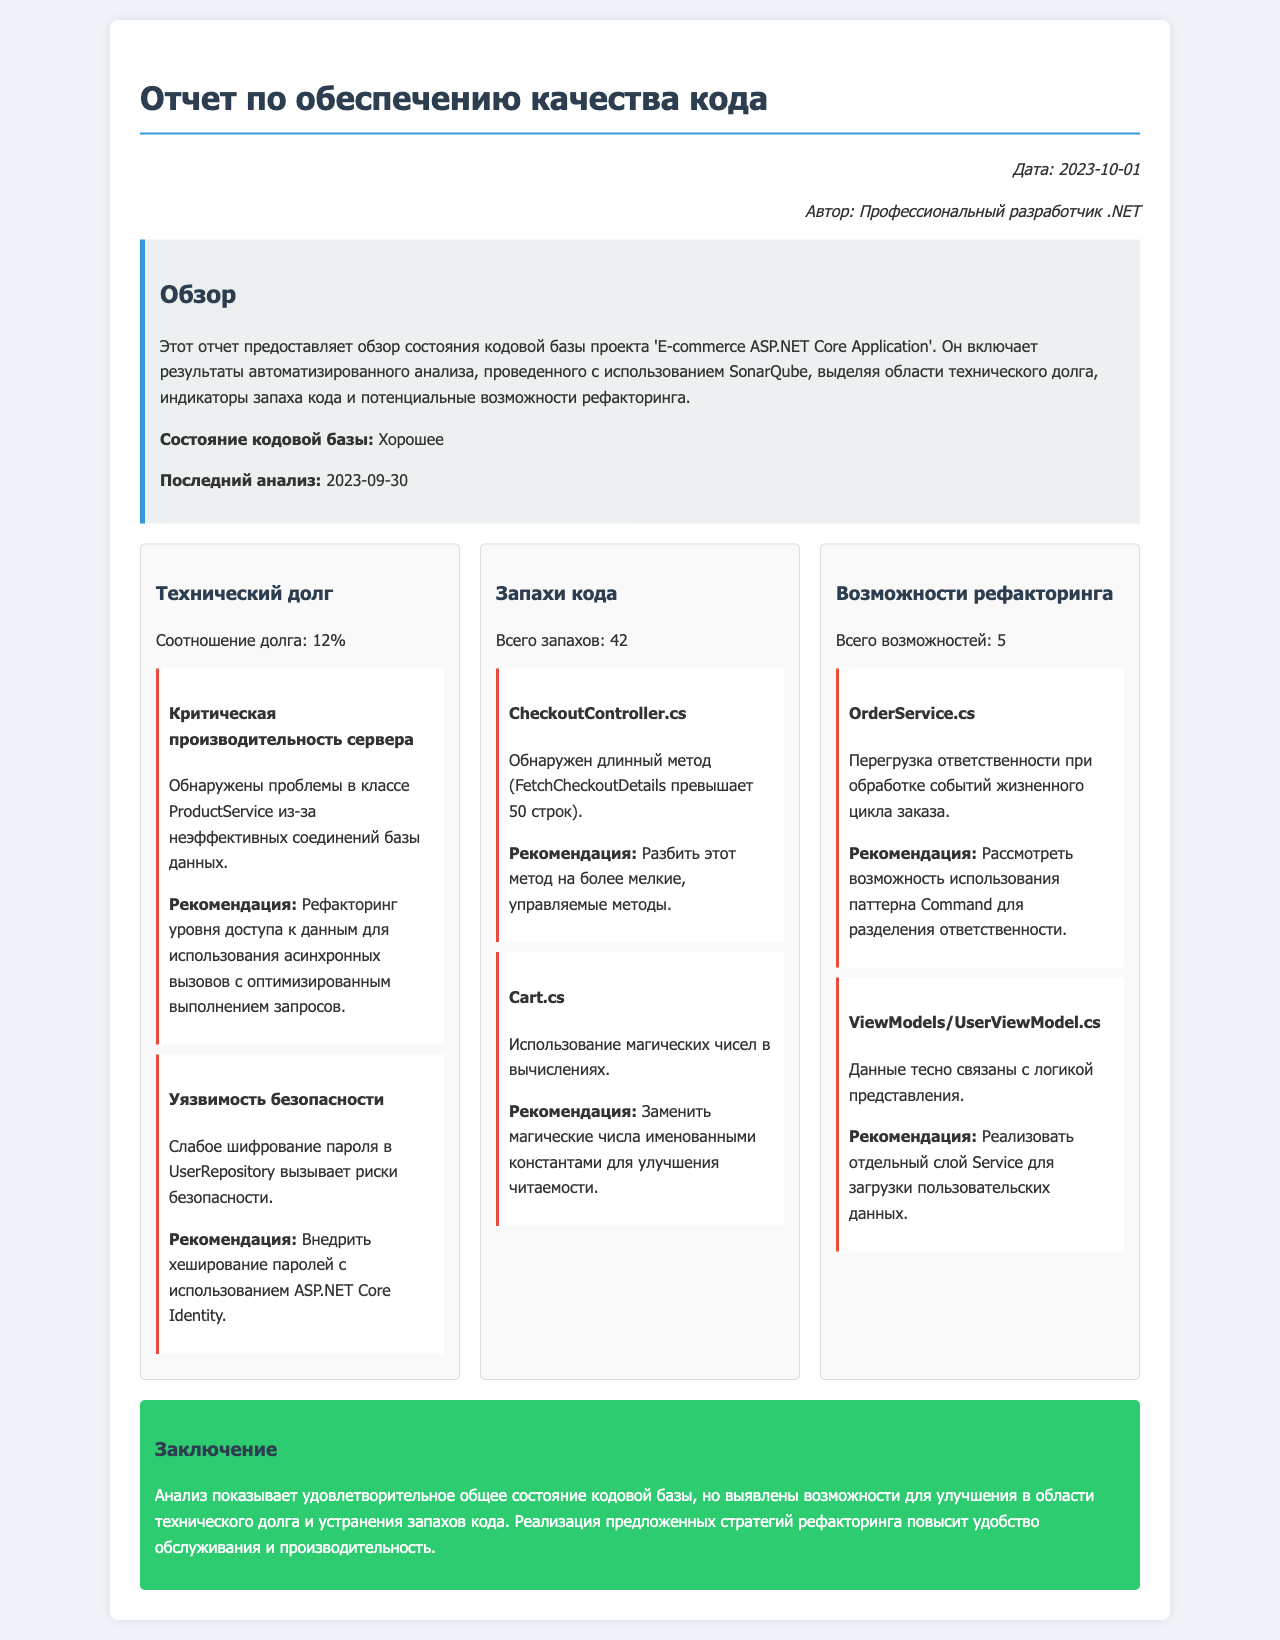Что представляет собой отчет? Отчет предоставляет обзор состояния кодовой базы проекта 'E-commerce ASP.NET Core Application'.
Answer: Обзор состояния кодовой базы Какова дата последнего анализа? Последний анализ был проведен 2023-09-30.
Answer: 2023-09-30 Каково состояние кодовой базы? Состояние кодовой базы указано как хорошее.
Answer: Хорошее Сколько составляет отношение технического долга? Соотношение технического долга указано в отчете.
Answer: 12% Сколько всего запахов кода обнаружено? Всего запахов указано в разделе о запахах кода.
Answer: 42 Какая рекомендация дана для CheckoutController.cs? Рекомендация заключается в разбиении длинного метода на более мелкие, управляемые методы.
Answer: Разбить этот метод на более мелкие, управляемые методы Каковы рекомендации для UserRepository? Внедрить хеширование паролей с использованием ASP.NET Core Identity.
Answer: Внедрить хеширование паролей с использованием ASP.NET Core Identity Сколько всего возможностей для рефакторинга? В отчете указано количество возможностей для рефакторинга.
Answer: 5 Какой вывод сделан в заключении отчета? Анализ показывает удовлетворительное общее состояние кодовой базы, но выявлены возможности для улучшения.
Answer: Удовлетворительное общее состояние кодовой базы 